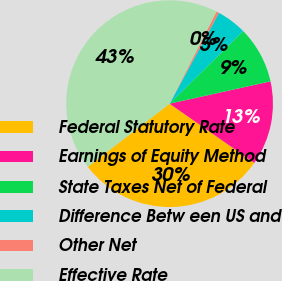<chart> <loc_0><loc_0><loc_500><loc_500><pie_chart><fcel>Federal Statutory Rate<fcel>Earnings of Equity Method<fcel>State Taxes Net of Federal<fcel>Difference Betw een US and<fcel>Other Net<fcel>Effective Rate<nl><fcel>29.83%<fcel>13.18%<fcel>8.93%<fcel>4.68%<fcel>0.43%<fcel>42.95%<nl></chart> 